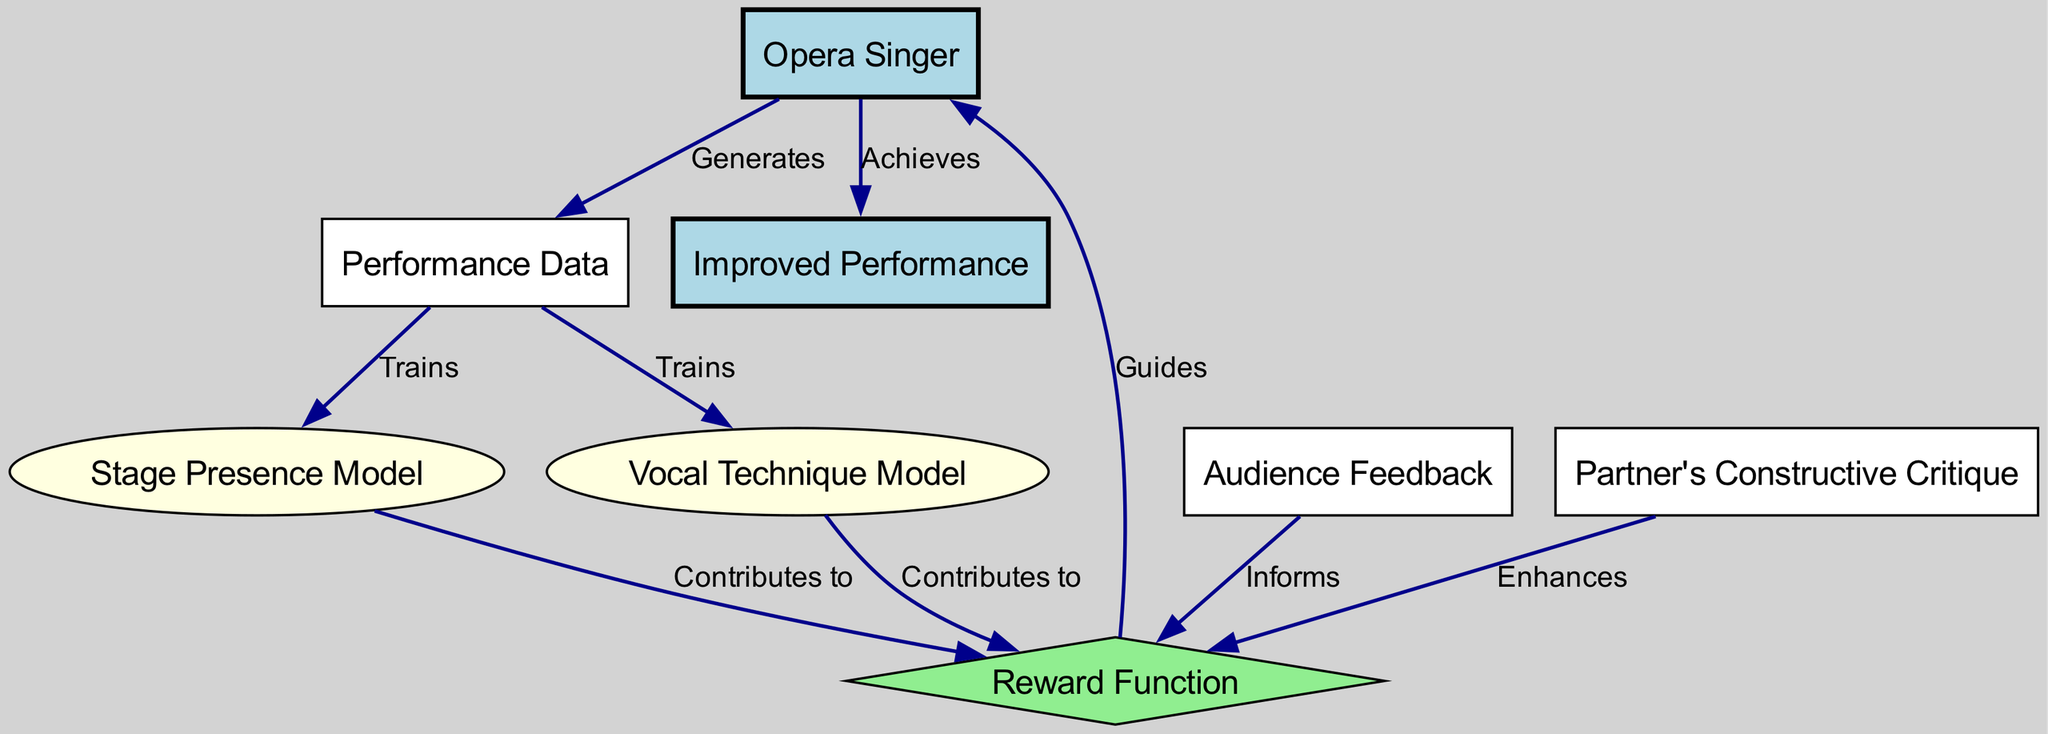What is the role of the Opera Singer in the diagram? The Opera Singer generates Performance Data as the initial action in the reinforcement learning process, making them a key starting point in improving their abilities.
Answer: Generates Performance Data How many nodes are in the diagram? By counting each unique entry in the "nodes" section, there are a total of eight distinct nodes representing different components in the reinforcement learning process.
Answer: Eight What informs the Reward Function in the diagram? The diagram indicates that both Audience Feedback and Partner's Constructive Critique contribute information to the Reward Function, guiding improvements.
Answer: Audience Feedback and Partner's Constructive Critique Which node is shaped like a diamond? In the diagram, the Reward Function is specifically represented as a diamond shape, indicating its unique role in the reinforcement learning process.
Answer: Reward Function What do the Performance Data nodes contribute to? Both the Stage Presence Model and Vocal Technique Model are trained using the Performance Data, showing their reliance on this node for development.
Answer: Trains What does the Reward Function guide? The diagram shows that the Reward Function provides guidance back to the Opera Singer, indicating its influence on the singer's actions based on feedback and performance quality.
Answer: The Opera Singer How does the Stage Presence Model contribute to the process? The diagram indicates that the Stage Presence Model contributes information to the Reward Function, thus affecting the guidance provided to the Opera Singer based on their stage presence.
Answer: Contributes to the Reward Function What is achieved as the final output in the diagram? The final output described in the diagram is the Improved Performance by the Opera Singer, which represents successful completion of the learning process.
Answer: Improved Performance 